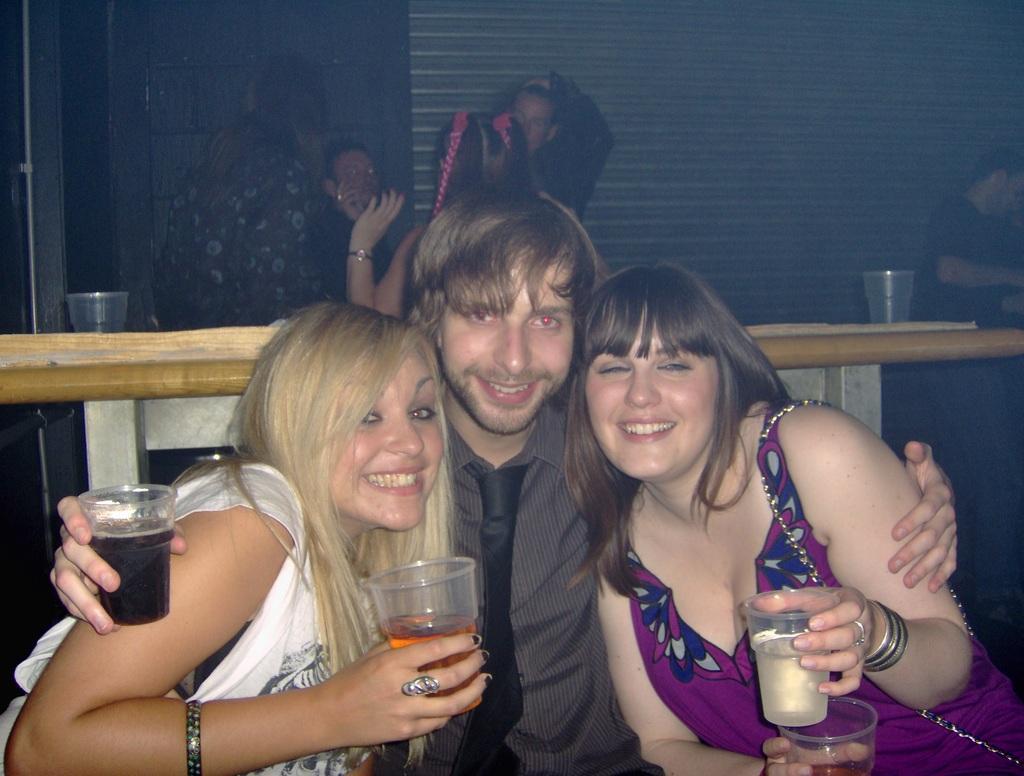Could you give a brief overview of what you see in this image? This picture is clicked inside. In the foreground we can see the two men and a woman wearing shirt, tie and all of them are smiling, holding glasses of drinks and seems to be sitting. In the background we can see a wooden table on the top of which glasses and some items are placed and we can see the group of persons and we can see the wall. 